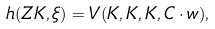<formula> <loc_0><loc_0><loc_500><loc_500>h ( Z K , \xi ) = V ( K , K , K , C \cdot w ) ,</formula> 